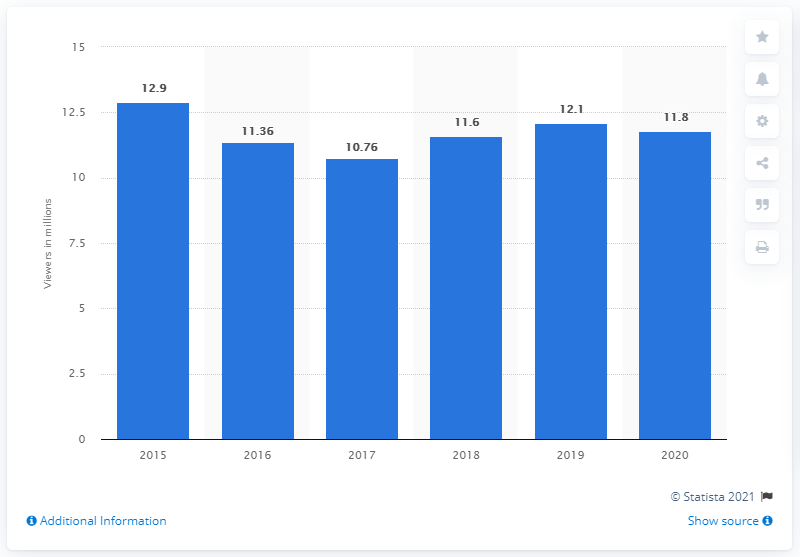List a handful of essential elements in this visual. During the 2020 NFL regular season, Monday Night Football was watched by 11.8 viewers on average. 